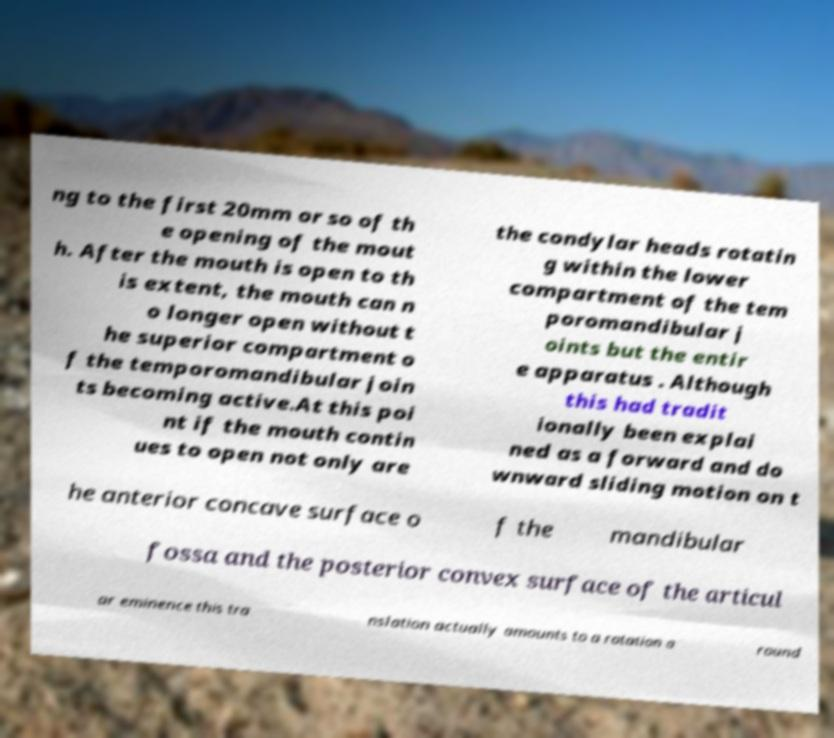Please read and relay the text visible in this image. What does it say? ng to the first 20mm or so of th e opening of the mout h. After the mouth is open to th is extent, the mouth can n o longer open without t he superior compartment o f the temporomandibular join ts becoming active.At this poi nt if the mouth contin ues to open not only are the condylar heads rotatin g within the lower compartment of the tem poromandibular j oints but the entir e apparatus . Although this had tradit ionally been explai ned as a forward and do wnward sliding motion on t he anterior concave surface o f the mandibular fossa and the posterior convex surface of the articul ar eminence this tra nslation actually amounts to a rotation a round 